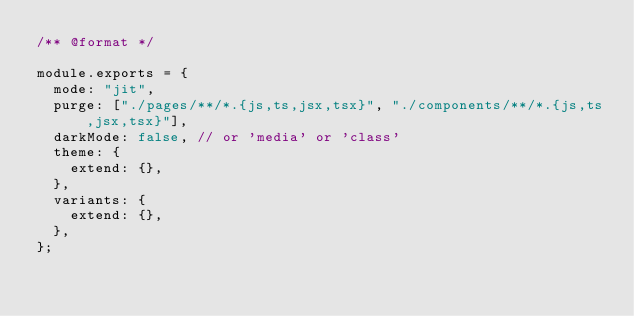<code> <loc_0><loc_0><loc_500><loc_500><_JavaScript_>/** @format */

module.exports = {
	mode: "jit",
	purge: ["./pages/**/*.{js,ts,jsx,tsx}", "./components/**/*.{js,ts,jsx,tsx}"],
	darkMode: false, // or 'media' or 'class'
	theme: {
		extend: {},
	},
	variants: {
		extend: {},
	},
};
</code> 